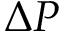Convert formula to latex. <formula><loc_0><loc_0><loc_500><loc_500>\Delta P</formula> 